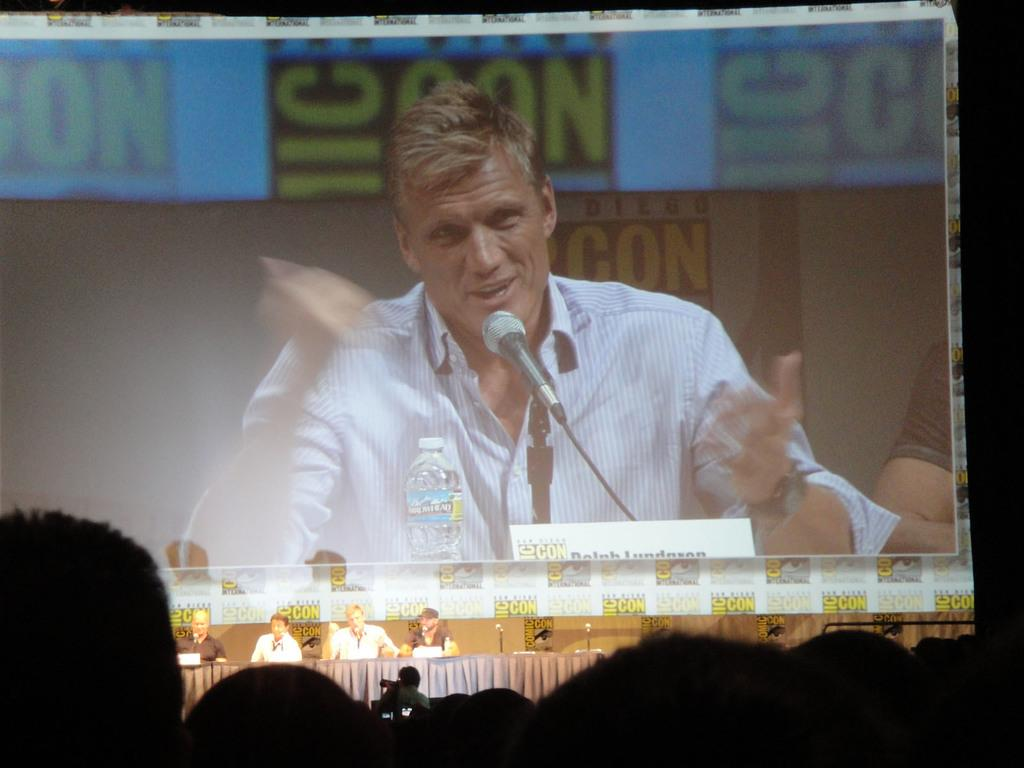What is the main feature of the image? There is a stage in the image. What are the people on the stage doing? Some people are sitting and talking on the stage. How can the information about the stage be accessed? The information about the stage is displayed on a display board. What type of animal can be seen sitting on the furniture in the image? There is no animal or furniture present in the image; it features a stage with people talking and a display board. 